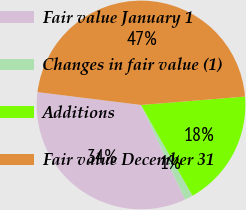Convert chart. <chart><loc_0><loc_0><loc_500><loc_500><pie_chart><fcel>Fair value January 1<fcel>Changes in fair value (1)<fcel>Additions<fcel>Fair value December 31<nl><fcel>33.91%<fcel>1.27%<fcel>18.07%<fcel>46.75%<nl></chart> 